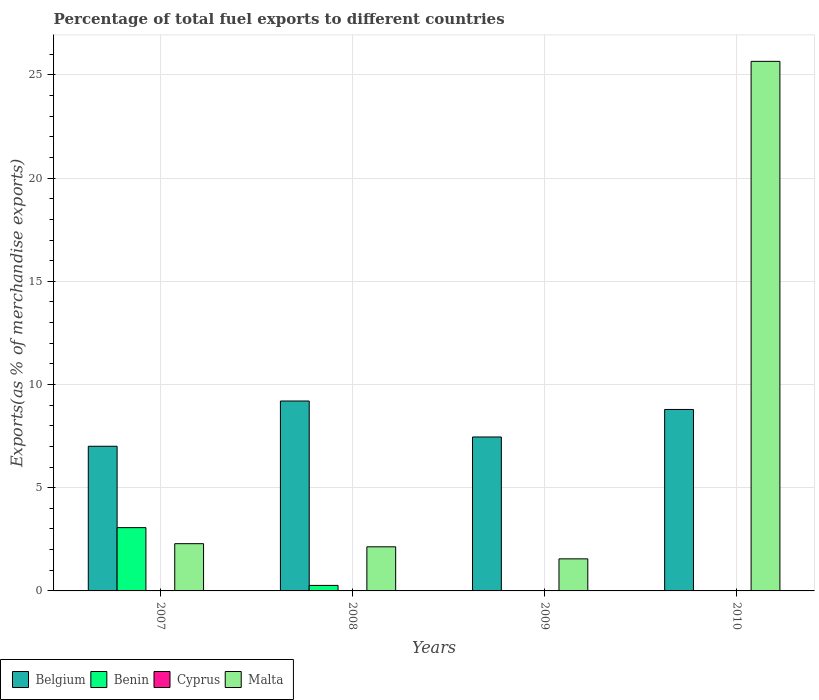How many groups of bars are there?
Your response must be concise. 4. Are the number of bars per tick equal to the number of legend labels?
Provide a short and direct response. Yes. Are the number of bars on each tick of the X-axis equal?
Your response must be concise. Yes. How many bars are there on the 1st tick from the left?
Ensure brevity in your answer.  4. What is the label of the 3rd group of bars from the left?
Give a very brief answer. 2009. In how many cases, is the number of bars for a given year not equal to the number of legend labels?
Keep it short and to the point. 0. What is the percentage of exports to different countries in Benin in 2009?
Provide a succinct answer. 0.01. Across all years, what is the maximum percentage of exports to different countries in Malta?
Provide a short and direct response. 25.66. Across all years, what is the minimum percentage of exports to different countries in Malta?
Offer a very short reply. 1.55. What is the total percentage of exports to different countries in Belgium in the graph?
Offer a terse response. 32.46. What is the difference between the percentage of exports to different countries in Malta in 2008 and that in 2009?
Give a very brief answer. 0.58. What is the difference between the percentage of exports to different countries in Cyprus in 2008 and the percentage of exports to different countries in Belgium in 2007?
Keep it short and to the point. -7. What is the average percentage of exports to different countries in Benin per year?
Your answer should be compact. 0.84. In the year 2009, what is the difference between the percentage of exports to different countries in Malta and percentage of exports to different countries in Belgium?
Your answer should be very brief. -5.9. What is the ratio of the percentage of exports to different countries in Benin in 2008 to that in 2010?
Offer a very short reply. 24.86. Is the difference between the percentage of exports to different countries in Malta in 2007 and 2010 greater than the difference between the percentage of exports to different countries in Belgium in 2007 and 2010?
Your answer should be very brief. No. What is the difference between the highest and the second highest percentage of exports to different countries in Benin?
Make the answer very short. 2.8. What is the difference between the highest and the lowest percentage of exports to different countries in Benin?
Ensure brevity in your answer.  3.06. Is the sum of the percentage of exports to different countries in Malta in 2009 and 2010 greater than the maximum percentage of exports to different countries in Benin across all years?
Your answer should be compact. Yes. What does the 2nd bar from the left in 2008 represents?
Keep it short and to the point. Benin. What does the 3rd bar from the right in 2007 represents?
Keep it short and to the point. Benin. Is it the case that in every year, the sum of the percentage of exports to different countries in Belgium and percentage of exports to different countries in Malta is greater than the percentage of exports to different countries in Cyprus?
Ensure brevity in your answer.  Yes. How many years are there in the graph?
Your answer should be compact. 4. Does the graph contain any zero values?
Offer a terse response. No. Does the graph contain grids?
Offer a very short reply. Yes. Where does the legend appear in the graph?
Your answer should be compact. Bottom left. How many legend labels are there?
Your answer should be compact. 4. What is the title of the graph?
Make the answer very short. Percentage of total fuel exports to different countries. Does "Austria" appear as one of the legend labels in the graph?
Make the answer very short. No. What is the label or title of the X-axis?
Offer a very short reply. Years. What is the label or title of the Y-axis?
Provide a succinct answer. Exports(as % of merchandise exports). What is the Exports(as % of merchandise exports) in Belgium in 2007?
Provide a short and direct response. 7.01. What is the Exports(as % of merchandise exports) in Benin in 2007?
Ensure brevity in your answer.  3.07. What is the Exports(as % of merchandise exports) in Cyprus in 2007?
Keep it short and to the point. 0.01. What is the Exports(as % of merchandise exports) of Malta in 2007?
Your response must be concise. 2.29. What is the Exports(as % of merchandise exports) in Belgium in 2008?
Make the answer very short. 9.2. What is the Exports(as % of merchandise exports) in Benin in 2008?
Ensure brevity in your answer.  0.27. What is the Exports(as % of merchandise exports) of Cyprus in 2008?
Ensure brevity in your answer.  0. What is the Exports(as % of merchandise exports) of Malta in 2008?
Provide a short and direct response. 2.14. What is the Exports(as % of merchandise exports) in Belgium in 2009?
Your answer should be compact. 7.46. What is the Exports(as % of merchandise exports) in Benin in 2009?
Ensure brevity in your answer.  0.01. What is the Exports(as % of merchandise exports) of Cyprus in 2009?
Provide a succinct answer. 0. What is the Exports(as % of merchandise exports) of Malta in 2009?
Offer a very short reply. 1.55. What is the Exports(as % of merchandise exports) in Belgium in 2010?
Your answer should be compact. 8.79. What is the Exports(as % of merchandise exports) in Benin in 2010?
Offer a very short reply. 0.01. What is the Exports(as % of merchandise exports) in Cyprus in 2010?
Keep it short and to the point. 0. What is the Exports(as % of merchandise exports) of Malta in 2010?
Keep it short and to the point. 25.66. Across all years, what is the maximum Exports(as % of merchandise exports) in Belgium?
Your answer should be compact. 9.2. Across all years, what is the maximum Exports(as % of merchandise exports) of Benin?
Your answer should be very brief. 3.07. Across all years, what is the maximum Exports(as % of merchandise exports) in Cyprus?
Your answer should be very brief. 0.01. Across all years, what is the maximum Exports(as % of merchandise exports) in Malta?
Keep it short and to the point. 25.66. Across all years, what is the minimum Exports(as % of merchandise exports) in Belgium?
Offer a very short reply. 7.01. Across all years, what is the minimum Exports(as % of merchandise exports) in Benin?
Your answer should be compact. 0.01. Across all years, what is the minimum Exports(as % of merchandise exports) of Cyprus?
Offer a very short reply. 0. Across all years, what is the minimum Exports(as % of merchandise exports) in Malta?
Make the answer very short. 1.55. What is the total Exports(as % of merchandise exports) in Belgium in the graph?
Provide a succinct answer. 32.46. What is the total Exports(as % of merchandise exports) in Benin in the graph?
Your answer should be very brief. 3.35. What is the total Exports(as % of merchandise exports) of Cyprus in the graph?
Ensure brevity in your answer.  0.02. What is the total Exports(as % of merchandise exports) in Malta in the graph?
Keep it short and to the point. 31.64. What is the difference between the Exports(as % of merchandise exports) of Belgium in 2007 and that in 2008?
Offer a very short reply. -2.19. What is the difference between the Exports(as % of merchandise exports) in Benin in 2007 and that in 2008?
Your answer should be compact. 2.8. What is the difference between the Exports(as % of merchandise exports) in Cyprus in 2007 and that in 2008?
Make the answer very short. 0. What is the difference between the Exports(as % of merchandise exports) in Malta in 2007 and that in 2008?
Make the answer very short. 0.15. What is the difference between the Exports(as % of merchandise exports) in Belgium in 2007 and that in 2009?
Provide a succinct answer. -0.45. What is the difference between the Exports(as % of merchandise exports) of Benin in 2007 and that in 2009?
Provide a short and direct response. 3.06. What is the difference between the Exports(as % of merchandise exports) in Cyprus in 2007 and that in 2009?
Your answer should be very brief. 0.01. What is the difference between the Exports(as % of merchandise exports) in Malta in 2007 and that in 2009?
Provide a succinct answer. 0.74. What is the difference between the Exports(as % of merchandise exports) of Belgium in 2007 and that in 2010?
Your answer should be compact. -1.78. What is the difference between the Exports(as % of merchandise exports) in Benin in 2007 and that in 2010?
Your answer should be very brief. 3.06. What is the difference between the Exports(as % of merchandise exports) of Cyprus in 2007 and that in 2010?
Your answer should be very brief. 0.01. What is the difference between the Exports(as % of merchandise exports) of Malta in 2007 and that in 2010?
Offer a very short reply. -23.37. What is the difference between the Exports(as % of merchandise exports) of Belgium in 2008 and that in 2009?
Make the answer very short. 1.74. What is the difference between the Exports(as % of merchandise exports) of Benin in 2008 and that in 2009?
Provide a succinct answer. 0.26. What is the difference between the Exports(as % of merchandise exports) of Cyprus in 2008 and that in 2009?
Keep it short and to the point. 0. What is the difference between the Exports(as % of merchandise exports) of Malta in 2008 and that in 2009?
Offer a terse response. 0.58. What is the difference between the Exports(as % of merchandise exports) of Belgium in 2008 and that in 2010?
Make the answer very short. 0.41. What is the difference between the Exports(as % of merchandise exports) of Benin in 2008 and that in 2010?
Your answer should be very brief. 0.26. What is the difference between the Exports(as % of merchandise exports) in Cyprus in 2008 and that in 2010?
Make the answer very short. 0. What is the difference between the Exports(as % of merchandise exports) in Malta in 2008 and that in 2010?
Your response must be concise. -23.52. What is the difference between the Exports(as % of merchandise exports) in Belgium in 2009 and that in 2010?
Offer a terse response. -1.33. What is the difference between the Exports(as % of merchandise exports) in Benin in 2009 and that in 2010?
Offer a very short reply. -0. What is the difference between the Exports(as % of merchandise exports) in Cyprus in 2009 and that in 2010?
Offer a very short reply. -0. What is the difference between the Exports(as % of merchandise exports) in Malta in 2009 and that in 2010?
Make the answer very short. -24.1. What is the difference between the Exports(as % of merchandise exports) in Belgium in 2007 and the Exports(as % of merchandise exports) in Benin in 2008?
Keep it short and to the point. 6.74. What is the difference between the Exports(as % of merchandise exports) in Belgium in 2007 and the Exports(as % of merchandise exports) in Cyprus in 2008?
Your response must be concise. 7. What is the difference between the Exports(as % of merchandise exports) in Belgium in 2007 and the Exports(as % of merchandise exports) in Malta in 2008?
Your response must be concise. 4.87. What is the difference between the Exports(as % of merchandise exports) of Benin in 2007 and the Exports(as % of merchandise exports) of Cyprus in 2008?
Offer a very short reply. 3.06. What is the difference between the Exports(as % of merchandise exports) of Benin in 2007 and the Exports(as % of merchandise exports) of Malta in 2008?
Keep it short and to the point. 0.93. What is the difference between the Exports(as % of merchandise exports) of Cyprus in 2007 and the Exports(as % of merchandise exports) of Malta in 2008?
Keep it short and to the point. -2.13. What is the difference between the Exports(as % of merchandise exports) of Belgium in 2007 and the Exports(as % of merchandise exports) of Benin in 2009?
Your answer should be very brief. 7. What is the difference between the Exports(as % of merchandise exports) of Belgium in 2007 and the Exports(as % of merchandise exports) of Cyprus in 2009?
Make the answer very short. 7.01. What is the difference between the Exports(as % of merchandise exports) of Belgium in 2007 and the Exports(as % of merchandise exports) of Malta in 2009?
Provide a short and direct response. 5.46. What is the difference between the Exports(as % of merchandise exports) of Benin in 2007 and the Exports(as % of merchandise exports) of Cyprus in 2009?
Provide a short and direct response. 3.07. What is the difference between the Exports(as % of merchandise exports) of Benin in 2007 and the Exports(as % of merchandise exports) of Malta in 2009?
Your answer should be compact. 1.51. What is the difference between the Exports(as % of merchandise exports) in Cyprus in 2007 and the Exports(as % of merchandise exports) in Malta in 2009?
Ensure brevity in your answer.  -1.55. What is the difference between the Exports(as % of merchandise exports) in Belgium in 2007 and the Exports(as % of merchandise exports) in Benin in 2010?
Ensure brevity in your answer.  7. What is the difference between the Exports(as % of merchandise exports) of Belgium in 2007 and the Exports(as % of merchandise exports) of Cyprus in 2010?
Provide a short and direct response. 7.01. What is the difference between the Exports(as % of merchandise exports) of Belgium in 2007 and the Exports(as % of merchandise exports) of Malta in 2010?
Your answer should be very brief. -18.65. What is the difference between the Exports(as % of merchandise exports) in Benin in 2007 and the Exports(as % of merchandise exports) in Cyprus in 2010?
Provide a succinct answer. 3.06. What is the difference between the Exports(as % of merchandise exports) of Benin in 2007 and the Exports(as % of merchandise exports) of Malta in 2010?
Offer a terse response. -22.59. What is the difference between the Exports(as % of merchandise exports) in Cyprus in 2007 and the Exports(as % of merchandise exports) in Malta in 2010?
Ensure brevity in your answer.  -25.65. What is the difference between the Exports(as % of merchandise exports) of Belgium in 2008 and the Exports(as % of merchandise exports) of Benin in 2009?
Make the answer very short. 9.19. What is the difference between the Exports(as % of merchandise exports) of Belgium in 2008 and the Exports(as % of merchandise exports) of Cyprus in 2009?
Ensure brevity in your answer.  9.2. What is the difference between the Exports(as % of merchandise exports) in Belgium in 2008 and the Exports(as % of merchandise exports) in Malta in 2009?
Provide a succinct answer. 7.65. What is the difference between the Exports(as % of merchandise exports) of Benin in 2008 and the Exports(as % of merchandise exports) of Cyprus in 2009?
Provide a short and direct response. 0.27. What is the difference between the Exports(as % of merchandise exports) of Benin in 2008 and the Exports(as % of merchandise exports) of Malta in 2009?
Ensure brevity in your answer.  -1.29. What is the difference between the Exports(as % of merchandise exports) of Cyprus in 2008 and the Exports(as % of merchandise exports) of Malta in 2009?
Offer a very short reply. -1.55. What is the difference between the Exports(as % of merchandise exports) in Belgium in 2008 and the Exports(as % of merchandise exports) in Benin in 2010?
Provide a short and direct response. 9.19. What is the difference between the Exports(as % of merchandise exports) in Belgium in 2008 and the Exports(as % of merchandise exports) in Cyprus in 2010?
Your answer should be very brief. 9.2. What is the difference between the Exports(as % of merchandise exports) in Belgium in 2008 and the Exports(as % of merchandise exports) in Malta in 2010?
Your answer should be compact. -16.46. What is the difference between the Exports(as % of merchandise exports) in Benin in 2008 and the Exports(as % of merchandise exports) in Cyprus in 2010?
Provide a short and direct response. 0.26. What is the difference between the Exports(as % of merchandise exports) of Benin in 2008 and the Exports(as % of merchandise exports) of Malta in 2010?
Provide a succinct answer. -25.39. What is the difference between the Exports(as % of merchandise exports) of Cyprus in 2008 and the Exports(as % of merchandise exports) of Malta in 2010?
Make the answer very short. -25.65. What is the difference between the Exports(as % of merchandise exports) of Belgium in 2009 and the Exports(as % of merchandise exports) of Benin in 2010?
Ensure brevity in your answer.  7.45. What is the difference between the Exports(as % of merchandise exports) of Belgium in 2009 and the Exports(as % of merchandise exports) of Cyprus in 2010?
Offer a terse response. 7.46. What is the difference between the Exports(as % of merchandise exports) of Belgium in 2009 and the Exports(as % of merchandise exports) of Malta in 2010?
Offer a terse response. -18.2. What is the difference between the Exports(as % of merchandise exports) of Benin in 2009 and the Exports(as % of merchandise exports) of Cyprus in 2010?
Your answer should be compact. 0.01. What is the difference between the Exports(as % of merchandise exports) of Benin in 2009 and the Exports(as % of merchandise exports) of Malta in 2010?
Provide a succinct answer. -25.65. What is the difference between the Exports(as % of merchandise exports) of Cyprus in 2009 and the Exports(as % of merchandise exports) of Malta in 2010?
Provide a succinct answer. -25.66. What is the average Exports(as % of merchandise exports) in Belgium per year?
Your answer should be very brief. 8.11. What is the average Exports(as % of merchandise exports) of Benin per year?
Give a very brief answer. 0.84. What is the average Exports(as % of merchandise exports) of Cyprus per year?
Provide a succinct answer. 0. What is the average Exports(as % of merchandise exports) in Malta per year?
Your response must be concise. 7.91. In the year 2007, what is the difference between the Exports(as % of merchandise exports) in Belgium and Exports(as % of merchandise exports) in Benin?
Offer a terse response. 3.94. In the year 2007, what is the difference between the Exports(as % of merchandise exports) in Belgium and Exports(as % of merchandise exports) in Cyprus?
Your response must be concise. 7. In the year 2007, what is the difference between the Exports(as % of merchandise exports) of Belgium and Exports(as % of merchandise exports) of Malta?
Give a very brief answer. 4.72. In the year 2007, what is the difference between the Exports(as % of merchandise exports) in Benin and Exports(as % of merchandise exports) in Cyprus?
Your response must be concise. 3.06. In the year 2007, what is the difference between the Exports(as % of merchandise exports) of Benin and Exports(as % of merchandise exports) of Malta?
Offer a terse response. 0.78. In the year 2007, what is the difference between the Exports(as % of merchandise exports) in Cyprus and Exports(as % of merchandise exports) in Malta?
Your answer should be very brief. -2.28. In the year 2008, what is the difference between the Exports(as % of merchandise exports) in Belgium and Exports(as % of merchandise exports) in Benin?
Provide a succinct answer. 8.93. In the year 2008, what is the difference between the Exports(as % of merchandise exports) in Belgium and Exports(as % of merchandise exports) in Cyprus?
Provide a short and direct response. 9.2. In the year 2008, what is the difference between the Exports(as % of merchandise exports) of Belgium and Exports(as % of merchandise exports) of Malta?
Provide a short and direct response. 7.06. In the year 2008, what is the difference between the Exports(as % of merchandise exports) of Benin and Exports(as % of merchandise exports) of Cyprus?
Ensure brevity in your answer.  0.26. In the year 2008, what is the difference between the Exports(as % of merchandise exports) in Benin and Exports(as % of merchandise exports) in Malta?
Offer a very short reply. -1.87. In the year 2008, what is the difference between the Exports(as % of merchandise exports) of Cyprus and Exports(as % of merchandise exports) of Malta?
Offer a very short reply. -2.13. In the year 2009, what is the difference between the Exports(as % of merchandise exports) of Belgium and Exports(as % of merchandise exports) of Benin?
Give a very brief answer. 7.45. In the year 2009, what is the difference between the Exports(as % of merchandise exports) in Belgium and Exports(as % of merchandise exports) in Cyprus?
Provide a succinct answer. 7.46. In the year 2009, what is the difference between the Exports(as % of merchandise exports) of Belgium and Exports(as % of merchandise exports) of Malta?
Offer a terse response. 5.9. In the year 2009, what is the difference between the Exports(as % of merchandise exports) of Benin and Exports(as % of merchandise exports) of Cyprus?
Make the answer very short. 0.01. In the year 2009, what is the difference between the Exports(as % of merchandise exports) of Benin and Exports(as % of merchandise exports) of Malta?
Offer a very short reply. -1.55. In the year 2009, what is the difference between the Exports(as % of merchandise exports) of Cyprus and Exports(as % of merchandise exports) of Malta?
Offer a very short reply. -1.55. In the year 2010, what is the difference between the Exports(as % of merchandise exports) in Belgium and Exports(as % of merchandise exports) in Benin?
Provide a succinct answer. 8.78. In the year 2010, what is the difference between the Exports(as % of merchandise exports) in Belgium and Exports(as % of merchandise exports) in Cyprus?
Make the answer very short. 8.79. In the year 2010, what is the difference between the Exports(as % of merchandise exports) of Belgium and Exports(as % of merchandise exports) of Malta?
Offer a very short reply. -16.87. In the year 2010, what is the difference between the Exports(as % of merchandise exports) in Benin and Exports(as % of merchandise exports) in Cyprus?
Offer a terse response. 0.01. In the year 2010, what is the difference between the Exports(as % of merchandise exports) of Benin and Exports(as % of merchandise exports) of Malta?
Make the answer very short. -25.65. In the year 2010, what is the difference between the Exports(as % of merchandise exports) of Cyprus and Exports(as % of merchandise exports) of Malta?
Offer a terse response. -25.65. What is the ratio of the Exports(as % of merchandise exports) in Belgium in 2007 to that in 2008?
Provide a succinct answer. 0.76. What is the ratio of the Exports(as % of merchandise exports) in Benin in 2007 to that in 2008?
Offer a terse response. 11.5. What is the ratio of the Exports(as % of merchandise exports) of Cyprus in 2007 to that in 2008?
Your answer should be very brief. 1.58. What is the ratio of the Exports(as % of merchandise exports) of Malta in 2007 to that in 2008?
Make the answer very short. 1.07. What is the ratio of the Exports(as % of merchandise exports) in Belgium in 2007 to that in 2009?
Offer a very short reply. 0.94. What is the ratio of the Exports(as % of merchandise exports) in Benin in 2007 to that in 2009?
Make the answer very short. 384.3. What is the ratio of the Exports(as % of merchandise exports) of Cyprus in 2007 to that in 2009?
Your response must be concise. 19.2. What is the ratio of the Exports(as % of merchandise exports) of Malta in 2007 to that in 2009?
Your answer should be compact. 1.47. What is the ratio of the Exports(as % of merchandise exports) in Belgium in 2007 to that in 2010?
Keep it short and to the point. 0.8. What is the ratio of the Exports(as % of merchandise exports) in Benin in 2007 to that in 2010?
Keep it short and to the point. 285.83. What is the ratio of the Exports(as % of merchandise exports) of Cyprus in 2007 to that in 2010?
Offer a terse response. 3.17. What is the ratio of the Exports(as % of merchandise exports) in Malta in 2007 to that in 2010?
Your answer should be compact. 0.09. What is the ratio of the Exports(as % of merchandise exports) in Belgium in 2008 to that in 2009?
Offer a terse response. 1.23. What is the ratio of the Exports(as % of merchandise exports) of Benin in 2008 to that in 2009?
Provide a succinct answer. 33.43. What is the ratio of the Exports(as % of merchandise exports) in Cyprus in 2008 to that in 2009?
Provide a succinct answer. 12.18. What is the ratio of the Exports(as % of merchandise exports) in Malta in 2008 to that in 2009?
Provide a succinct answer. 1.38. What is the ratio of the Exports(as % of merchandise exports) in Belgium in 2008 to that in 2010?
Provide a succinct answer. 1.05. What is the ratio of the Exports(as % of merchandise exports) of Benin in 2008 to that in 2010?
Offer a very short reply. 24.86. What is the ratio of the Exports(as % of merchandise exports) in Cyprus in 2008 to that in 2010?
Make the answer very short. 2.01. What is the ratio of the Exports(as % of merchandise exports) of Malta in 2008 to that in 2010?
Your answer should be very brief. 0.08. What is the ratio of the Exports(as % of merchandise exports) in Belgium in 2009 to that in 2010?
Provide a succinct answer. 0.85. What is the ratio of the Exports(as % of merchandise exports) of Benin in 2009 to that in 2010?
Ensure brevity in your answer.  0.74. What is the ratio of the Exports(as % of merchandise exports) in Cyprus in 2009 to that in 2010?
Give a very brief answer. 0.17. What is the ratio of the Exports(as % of merchandise exports) of Malta in 2009 to that in 2010?
Ensure brevity in your answer.  0.06. What is the difference between the highest and the second highest Exports(as % of merchandise exports) in Belgium?
Ensure brevity in your answer.  0.41. What is the difference between the highest and the second highest Exports(as % of merchandise exports) of Benin?
Keep it short and to the point. 2.8. What is the difference between the highest and the second highest Exports(as % of merchandise exports) of Cyprus?
Keep it short and to the point. 0. What is the difference between the highest and the second highest Exports(as % of merchandise exports) of Malta?
Give a very brief answer. 23.37. What is the difference between the highest and the lowest Exports(as % of merchandise exports) in Belgium?
Your response must be concise. 2.19. What is the difference between the highest and the lowest Exports(as % of merchandise exports) of Benin?
Give a very brief answer. 3.06. What is the difference between the highest and the lowest Exports(as % of merchandise exports) in Cyprus?
Your response must be concise. 0.01. What is the difference between the highest and the lowest Exports(as % of merchandise exports) in Malta?
Keep it short and to the point. 24.1. 